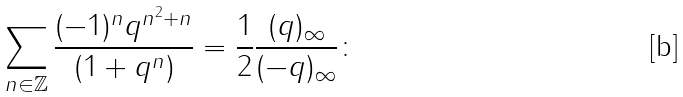<formula> <loc_0><loc_0><loc_500><loc_500>\sum _ { n \in \mathbb { Z } } \frac { ( - 1 ) ^ { n } q ^ { n ^ { 2 } + n } } { ( 1 + q ^ { n } ) } = \frac { 1 } { 2 } \frac { ( q ) _ { \infty } } { ( - q ) _ { \infty } } \colon</formula> 